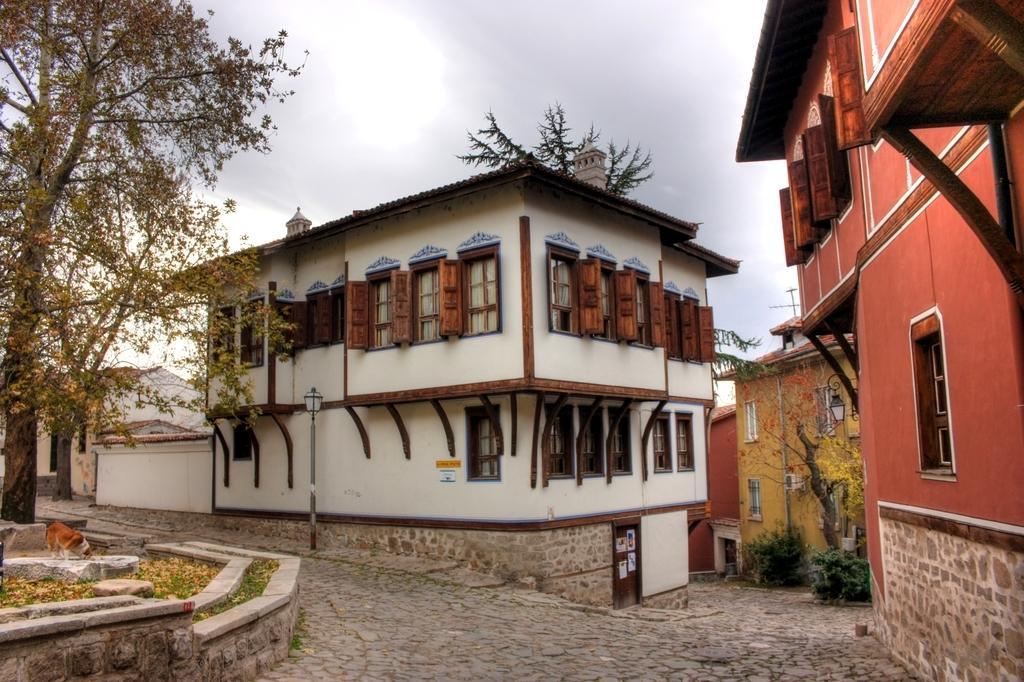Please provide a concise description of this image. In this image, there are a few buildings, trees, plants and a pole. We can see the ground and an animal. We can also see the sky. 